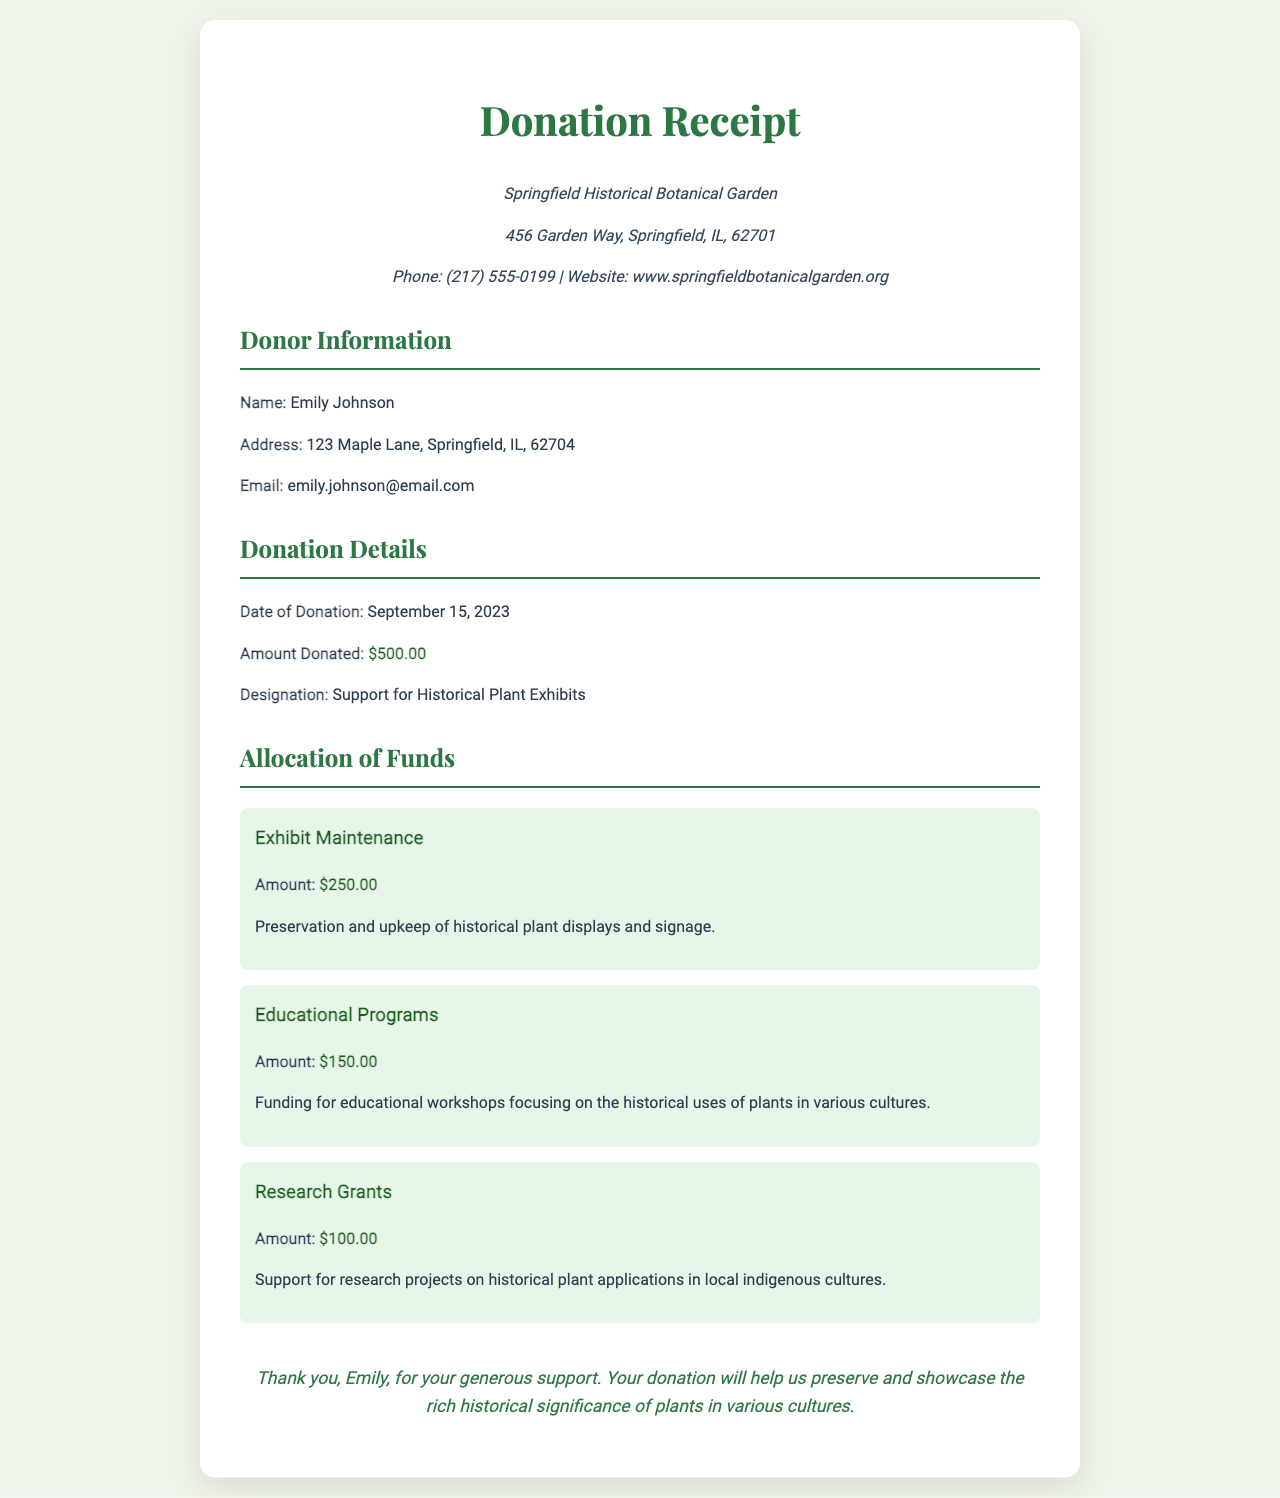What is the name of the donor? The donor's name is explicitly mentioned in the document under the donor information section.
Answer: Emily Johnson What is the amount donated? The donation details section specifies the amount of the donation.
Answer: $500.00 When was the donation made? The date of the donation is clearly listed in the donation details section.
Answer: September 15, 2023 What is the designation of the donation? The purpose of the donation is provided in the donation details section.
Answer: Support for Historical Plant Exhibits How much was allocated for exhibit maintenance? The allocation of funds section details the amount designated for exhibit maintenance.
Answer: $250.00 What portion of the donation is intended for educational programs? The educational programs funding amount is indicated under the allocation of funds section.
Answer: $150.00 What is the primary focus of the educational programs funded? The document specifies the focus of the educational programs within the allocation section.
Answer: Historical uses of plants in various cultures Who is thanked for their support in the receipt? The thank you section identifies the donor being acknowledged for their generosity.
Answer: Emily What is the address of the Springfield Historical Botanical Garden? The garden's address is explicitly provided in the garden info section.
Answer: 456 Garden Way, Springfield, IL, 62701 